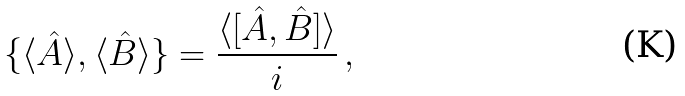Convert formula to latex. <formula><loc_0><loc_0><loc_500><loc_500>\{ \langle \hat { A } \rangle , \langle \hat { B } \rangle \} = \frac { \langle [ \hat { A } , \hat { B } ] \rangle } { i } \, ,</formula> 